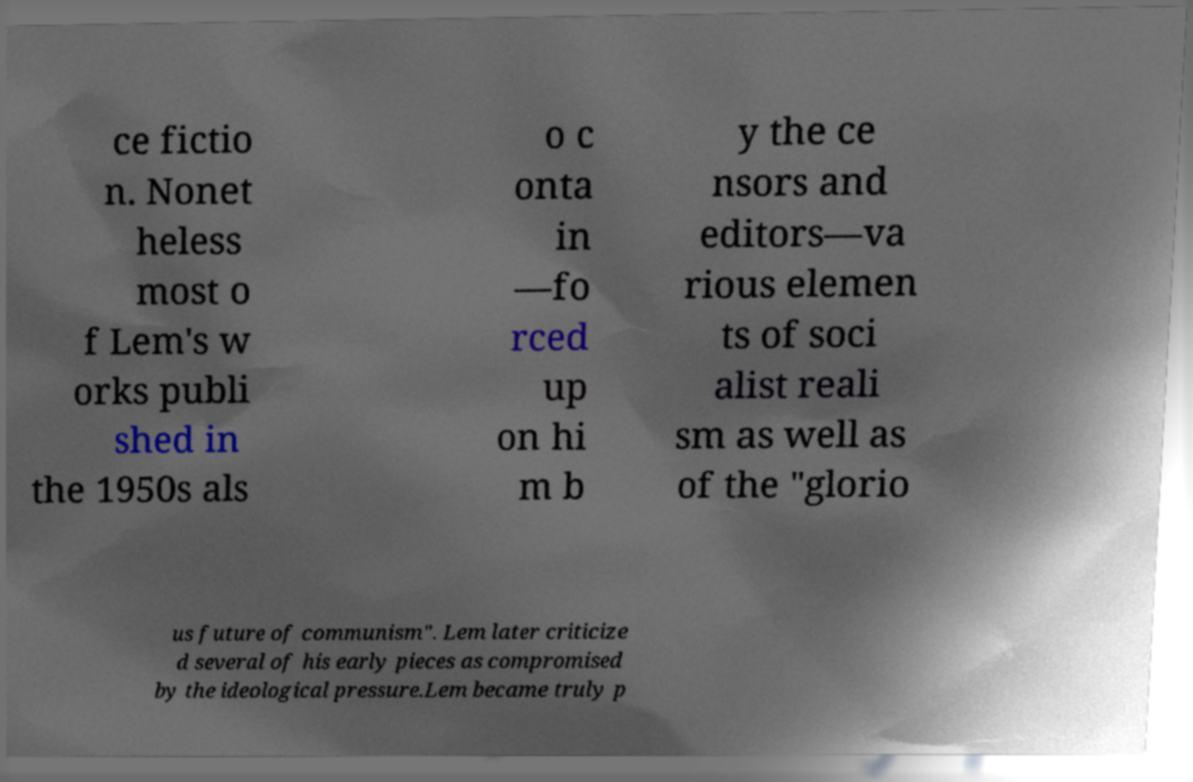What messages or text are displayed in this image? I need them in a readable, typed format. ce fictio n. Nonet heless most o f Lem's w orks publi shed in the 1950s als o c onta in —fo rced up on hi m b y the ce nsors and editors—va rious elemen ts of soci alist reali sm as well as of the "glorio us future of communism". Lem later criticize d several of his early pieces as compromised by the ideological pressure.Lem became truly p 